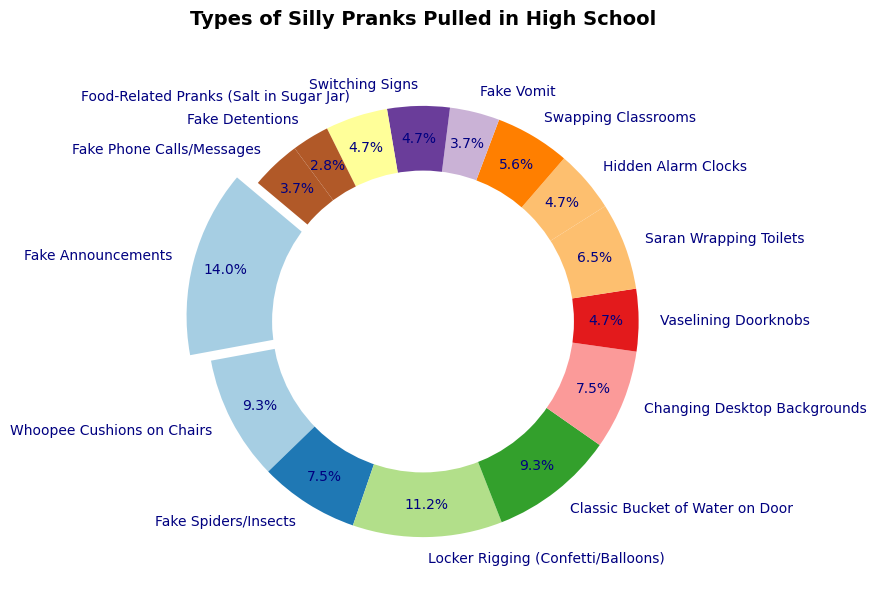What type of prank has the highest percentage? Look at the pie chart and identify the largest segment, which is noticeably highlighted. This segment is labeled 'Fake Announcements'. Here, 'Fake Announcements' represents the highest percentage.
Answer: Fake Announcements What is the combined percentage of 'Whoopee Cushions on Chairs' and 'Classic Bucket of Water on Door'? Identify the segments for 'Whoopee Cushions on Chairs' and 'Classic Bucket of Water on Door'. The chart shows 10% for 'Whoopee Cushions on Chairs' and 10% for 'Classic Bucket of Water on Door'. Summing them up gives 10% + 10% = 20%.
Answer: 20% Which pranks have an equal percentage representation on the chart? Scan each segment of the pie chart to find instances where segments have the same percentage. Segments labeled 'Hidden Alarm Clocks', 'Swapping Classrooms', 'Switching Signs' and 'Food-Related Pranks (Salt in Sugar Jar)' each have a 5% representation.
Answer: Hidden Alarm Clocks, Swapping Classrooms, Switching Signs, Food-Related Pranks How much larger is the percentage of 'Locker Rigging' compared to 'Vaselining Doorknobs'? Locate 'Locker Rigging (Confetti/Balloons)' and 'Vaselining Doorknobs' segments in the chart. 'Locker Rigging' is 12% and 'Vaselining Doorknobs' is 5%. The difference is 12% - 5% = 7%.
Answer: 7% What is the average percentage of the following pranks: 'Changing Desktop Backgrounds', 'Saran Wrapping Toilets', and 'Fake Vomit'? Find the percentages for these pranks: 'Changing Desktop Backgrounds' (8%), 'Saran Wrapping Toilets' (7%), and 'Fake Vomit' (4%). Calculate the average: (8% + 7% + 4%) / 3 = 19% / 3 ≈ 6.33%.
Answer: 6.33% Which segment visually appears to be the smallest? Observe the pie chart and identify the segment that is visually the smallest. The segment labeled 'Fake Detentions' is clearly the smallest.
Answer: Fake Detentions What's the percentage difference between the prank with the highest percentage and the prank with the lowest percentage? The prank with the highest percentage is 'Fake Announcements' (15%), and the prank with the lowest percentage is 'Fake Detentions' (3%). The difference is 15% - 3% = 12%.
Answer: 12% 